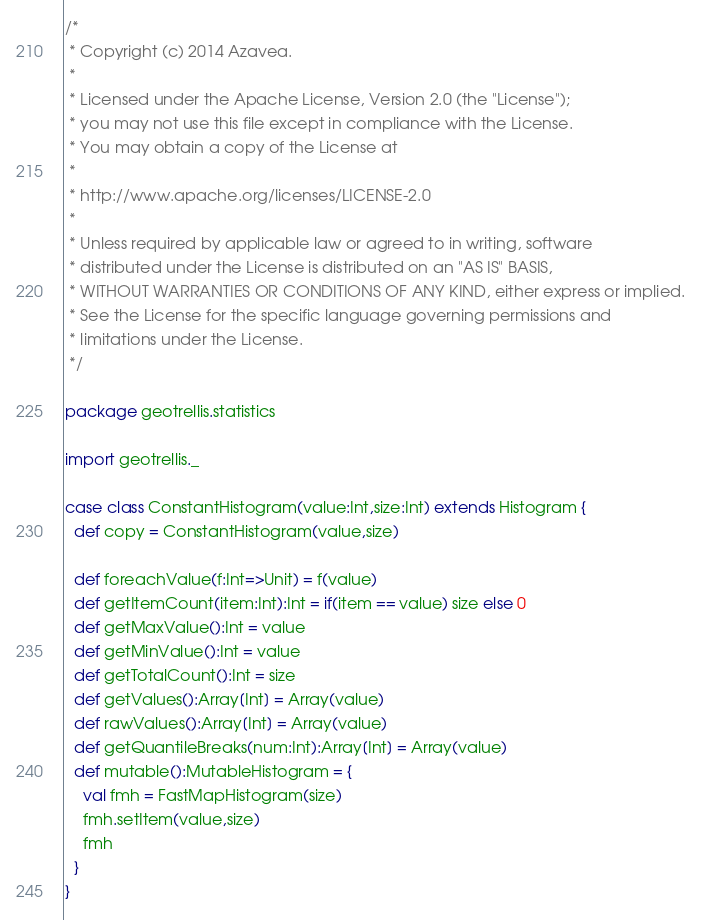<code> <loc_0><loc_0><loc_500><loc_500><_Scala_>/*
 * Copyright (c) 2014 Azavea.
 * 
 * Licensed under the Apache License, Version 2.0 (the "License");
 * you may not use this file except in compliance with the License.
 * You may obtain a copy of the License at
 * 
 * http://www.apache.org/licenses/LICENSE-2.0
 * 
 * Unless required by applicable law or agreed to in writing, software
 * distributed under the License is distributed on an "AS IS" BASIS,
 * WITHOUT WARRANTIES OR CONDITIONS OF ANY KIND, either express or implied.
 * See the License for the specific language governing permissions and
 * limitations under the License.
 */

package geotrellis.statistics

import geotrellis._

case class ConstantHistogram(value:Int,size:Int) extends Histogram {
  def copy = ConstantHistogram(value,size)

  def foreachValue(f:Int=>Unit) = f(value)
  def getItemCount(item:Int):Int = if(item == value) size else 0
  def getMaxValue():Int = value
  def getMinValue():Int = value
  def getTotalCount():Int = size
  def getValues():Array[Int] = Array(value)
  def rawValues():Array[Int] = Array(value)
  def getQuantileBreaks(num:Int):Array[Int] = Array(value)
  def mutable():MutableHistogram = {
    val fmh = FastMapHistogram(size)
    fmh.setItem(value,size)
    fmh
  }
}

</code> 